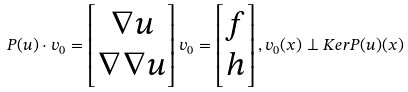Convert formula to latex. <formula><loc_0><loc_0><loc_500><loc_500>P ( u ) \cdot v _ { 0 } = \begin{bmatrix} \nabla u \\ \nabla \nabla u \end{bmatrix} v _ { 0 } = \begin{bmatrix} f \\ h \end{bmatrix} , v _ { 0 } ( x ) \perp K e r P ( u ) ( x )</formula> 